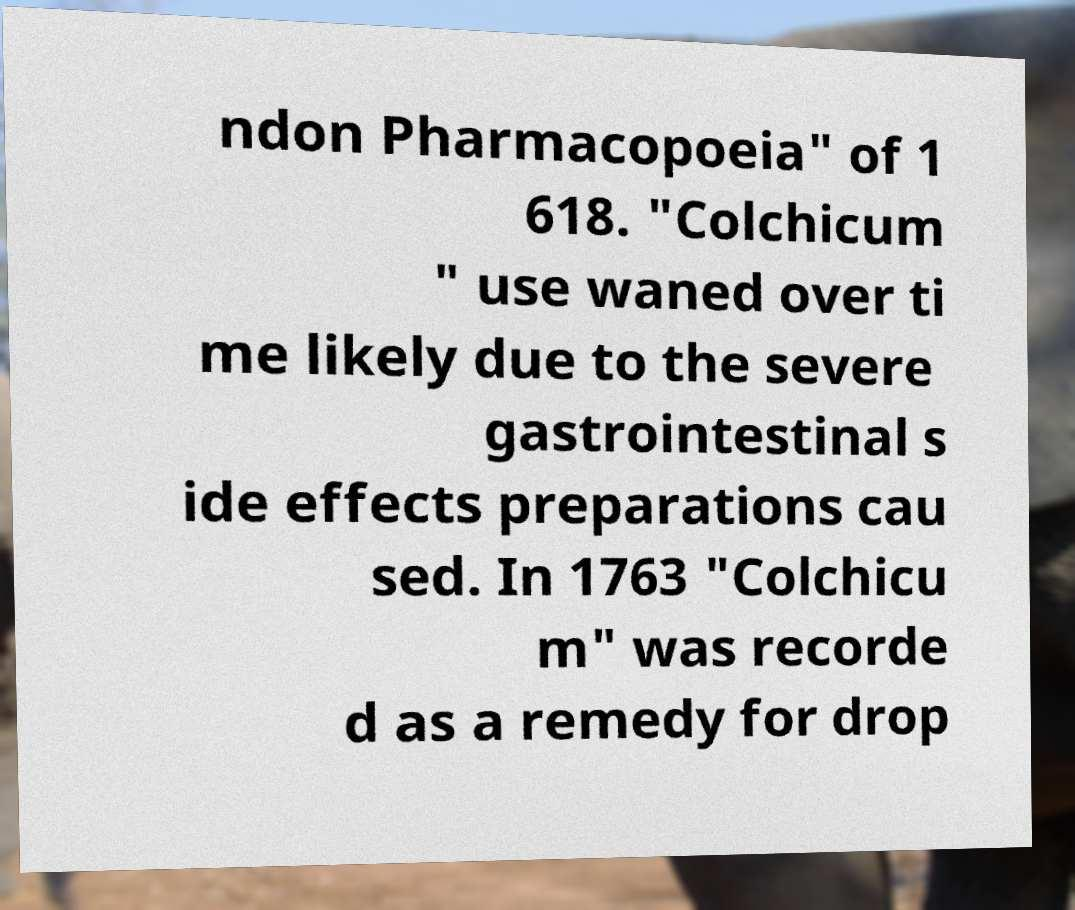Can you accurately transcribe the text from the provided image for me? ndon Pharmacopoeia" of 1 618. "Colchicum " use waned over ti me likely due to the severe gastrointestinal s ide effects preparations cau sed. In 1763 "Colchicu m" was recorde d as a remedy for drop 